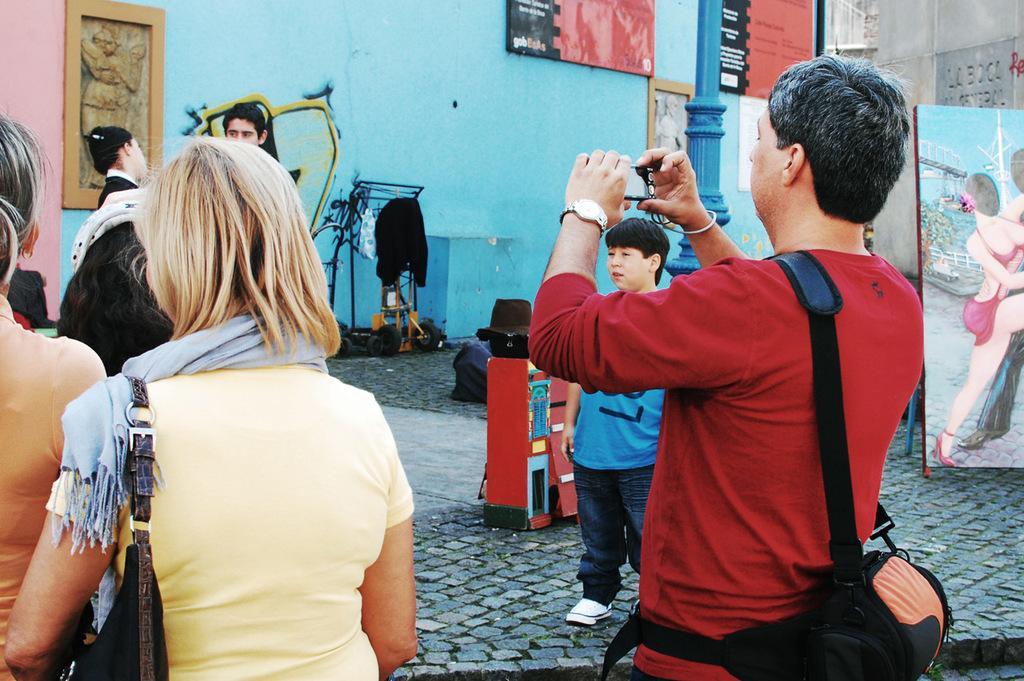In one or two sentences, can you explain what this image depicts? In this image we can see group of persons standing on the floor. In the background we can see paintings, kid, clothes, posters, building and wall. 